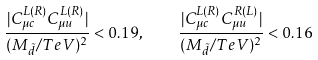Convert formula to latex. <formula><loc_0><loc_0><loc_500><loc_500>\frac { | C ^ { L ( R ) } _ { \mu c } C ^ { L ( R ) } _ { \mu u } | } { ( M _ { \tilde { d } } / T e V ) ^ { 2 } } < 0 . 1 9 , \quad \frac { | C ^ { L ( R ) } _ { \mu c } C ^ { R ( L ) } _ { \mu u } | } { ( M _ { \tilde { d } } / T e V ) ^ { 2 } } < 0 . 1 6</formula> 